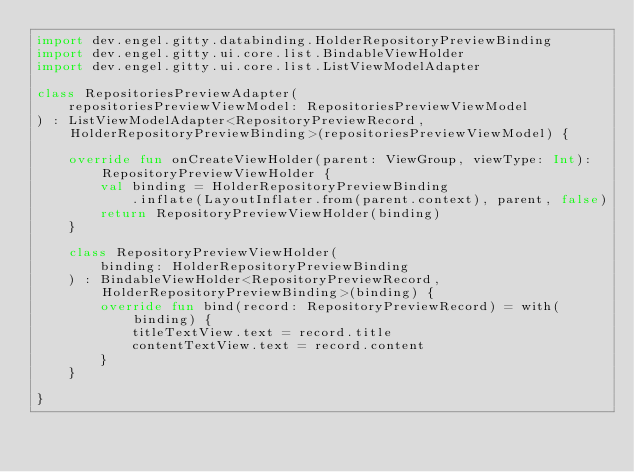Convert code to text. <code><loc_0><loc_0><loc_500><loc_500><_Kotlin_>import dev.engel.gitty.databinding.HolderRepositoryPreviewBinding
import dev.engel.gitty.ui.core.list.BindableViewHolder
import dev.engel.gitty.ui.core.list.ListViewModelAdapter

class RepositoriesPreviewAdapter(
    repositoriesPreviewViewModel: RepositoriesPreviewViewModel
) : ListViewModelAdapter<RepositoryPreviewRecord, HolderRepositoryPreviewBinding>(repositoriesPreviewViewModel) {

    override fun onCreateViewHolder(parent: ViewGroup, viewType: Int): RepositoryPreviewViewHolder {
        val binding = HolderRepositoryPreviewBinding
            .inflate(LayoutInflater.from(parent.context), parent, false)
        return RepositoryPreviewViewHolder(binding)
    }

    class RepositoryPreviewViewHolder(
        binding: HolderRepositoryPreviewBinding
    ) : BindableViewHolder<RepositoryPreviewRecord, HolderRepositoryPreviewBinding>(binding) {
        override fun bind(record: RepositoryPreviewRecord) = with(binding) {
            titleTextView.text = record.title
            contentTextView.text = record.content
        }
    }

}
</code> 